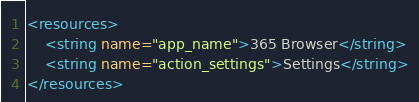Convert code to text. <code><loc_0><loc_0><loc_500><loc_500><_XML_><resources>
    <string name="app_name">365 Browser</string>
    <string name="action_settings">Settings</string>
</resources>
</code> 